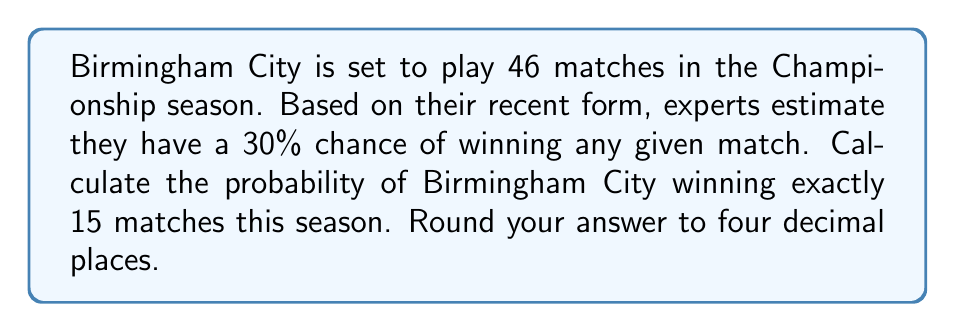What is the answer to this math problem? Let's approach this step-by-step using the binomial probability formula:

1) This is a binomial probability problem where:
   $n$ = 46 (total number of matches)
   $k$ = 15 (number of wins we're interested in)
   $p$ = 0.30 (probability of winning a single match)
   $q$ = 1 - $p$ = 0.70 (probability of not winning a single match)

2) The binomial probability formula is:

   $$P(X = k) = \binom{n}{k} p^k q^{n-k}$$

3) Let's calculate each part:
   
   $\binom{n}{k} = \binom{46}{15}$ = 3,190,187,286

4) $p^k = 0.30^{15}$ = 0.0000000047863

5) $q^{n-k} = 0.70^{31}$ = 0.0000000006561

6) Now, let's multiply these together:

   $$3,190,187,286 \times 0.0000000047863 \times 0.0000000006561 = 0.0100$$

7) Rounding to four decimal places gives us 0.0100.

This means there's a 1% chance of Birmingham City winning exactly 15 matches this season.
Answer: 0.0100 